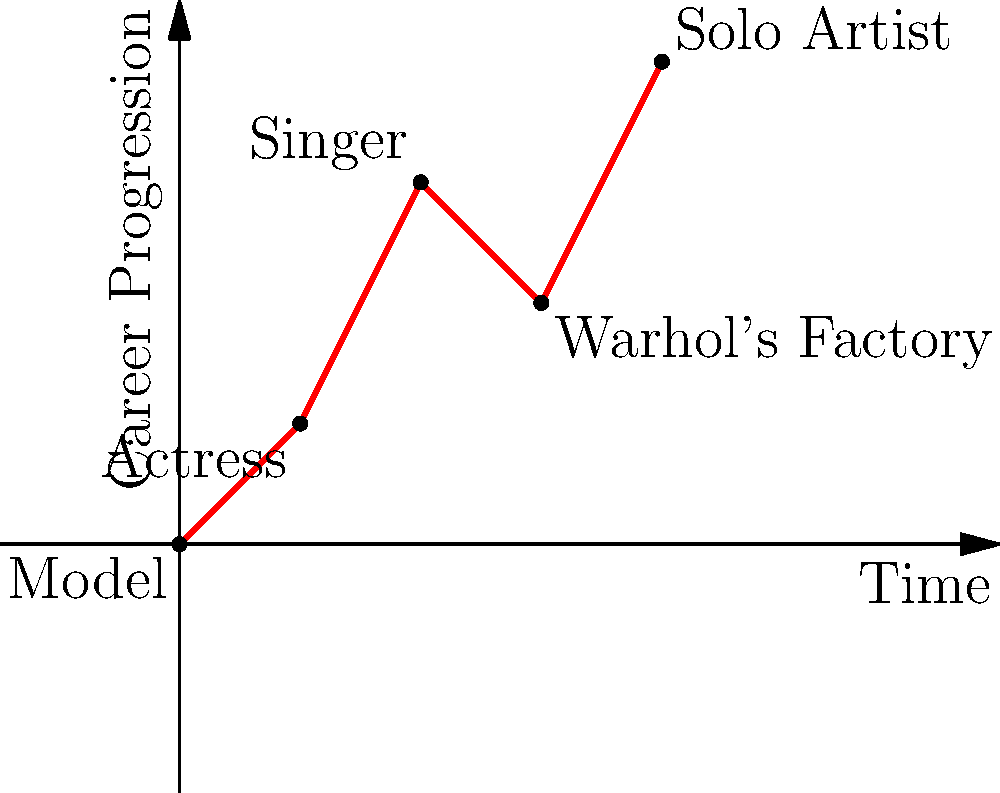Based on the vector path shown in the graph, which phase of Nico's career saw the most significant upward trajectory? To determine the phase of Nico's career with the most significant upward trajectory, we need to analyze the slope of each segment in the vector path:

1. Model to Actress (0,0) to (1,1): Slope = 1
2. Actress to Singer (1,1) to (2,3): Slope = 2
3. Singer to Warhol's Factory (2,3) to (3,2): Slope = -1 (downward)
4. Warhol's Factory to Solo Artist (3,2) to (4,4): Slope = 2

The steepest positive slope indicates the most significant upward trajectory. We can see that there are two segments with a slope of 2:
- Actress to Singer
- Warhol's Factory to Solo Artist

However, the question asks for a single phase. Considering Nico's career progression, the transition from Actress to Singer represents a more fundamental shift in her artistic focus and public persona. This phase marked her entry into the music world, which became central to her legacy.
Answer: Actress to Singer 